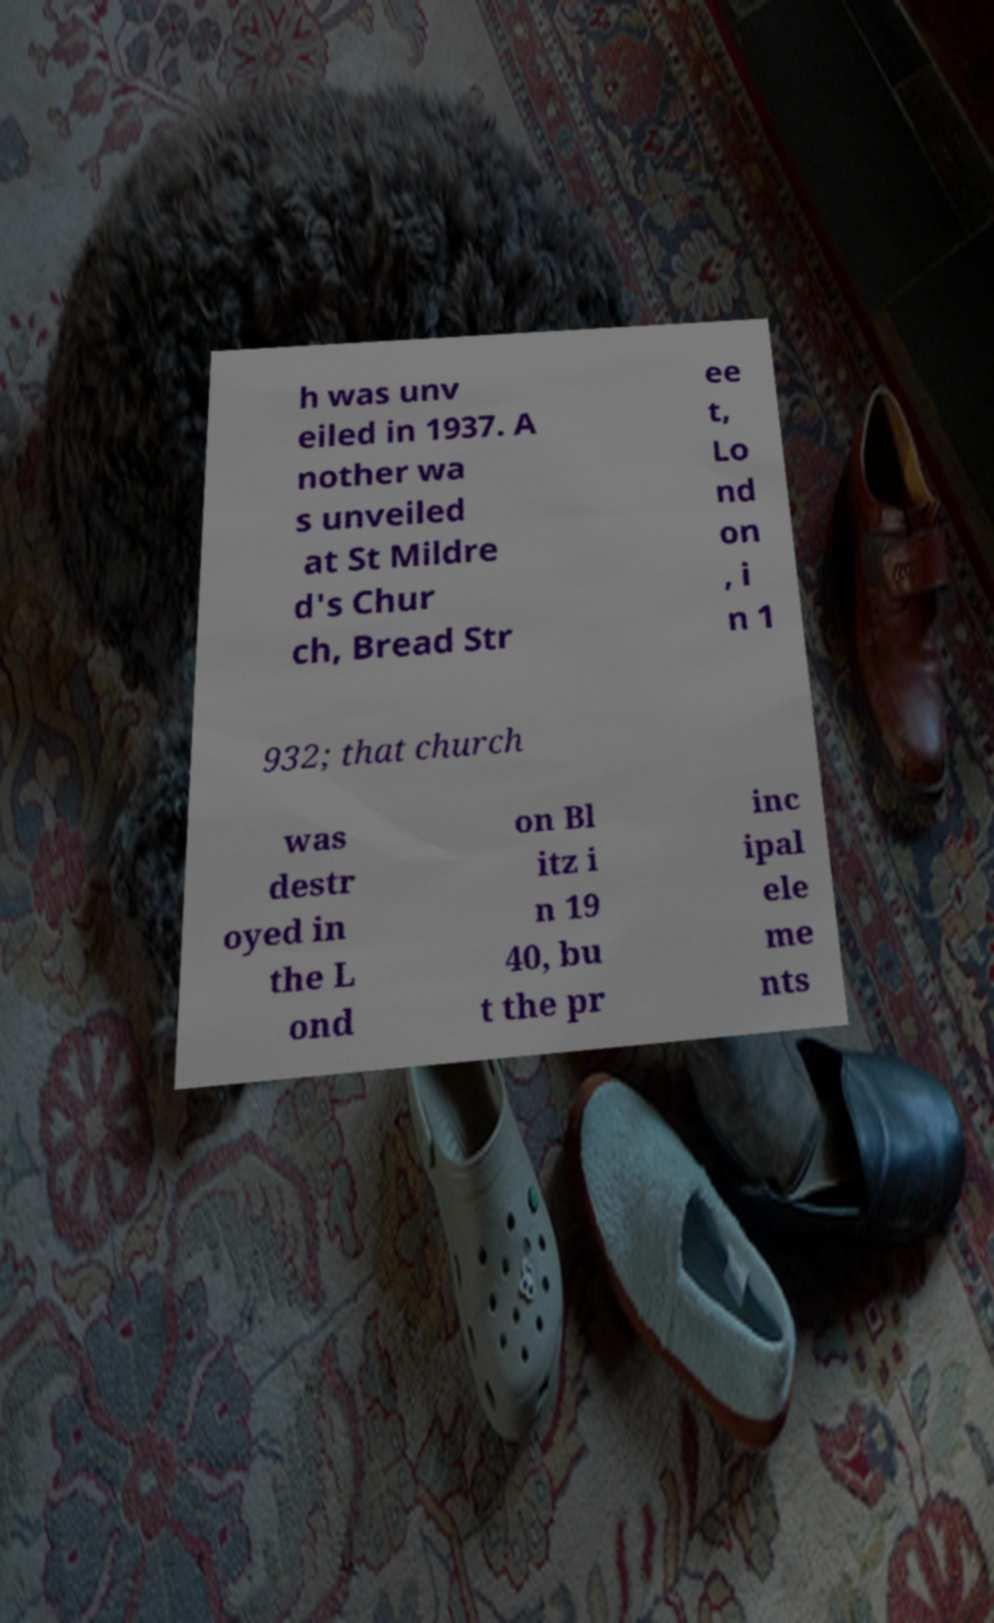For documentation purposes, I need the text within this image transcribed. Could you provide that? h was unv eiled in 1937. A nother wa s unveiled at St Mildre d's Chur ch, Bread Str ee t, Lo nd on , i n 1 932; that church was destr oyed in the L ond on Bl itz i n 19 40, bu t the pr inc ipal ele me nts 